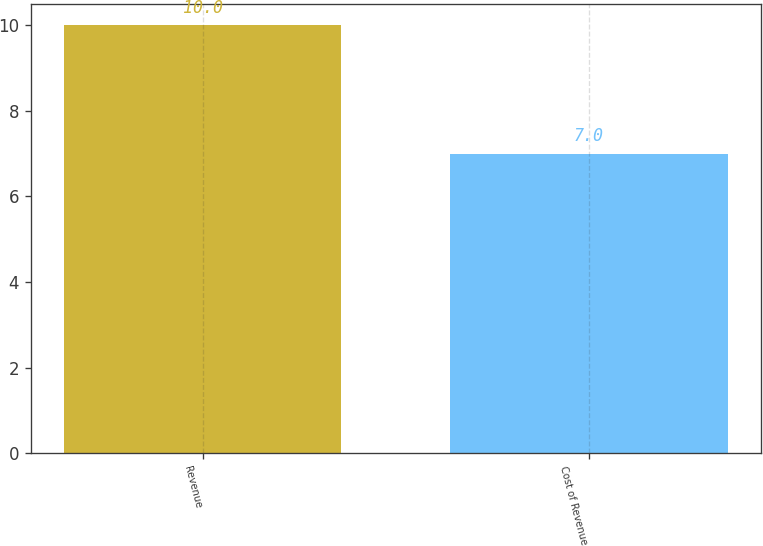<chart> <loc_0><loc_0><loc_500><loc_500><bar_chart><fcel>Revenue<fcel>Cost of Revenue<nl><fcel>10<fcel>7<nl></chart> 